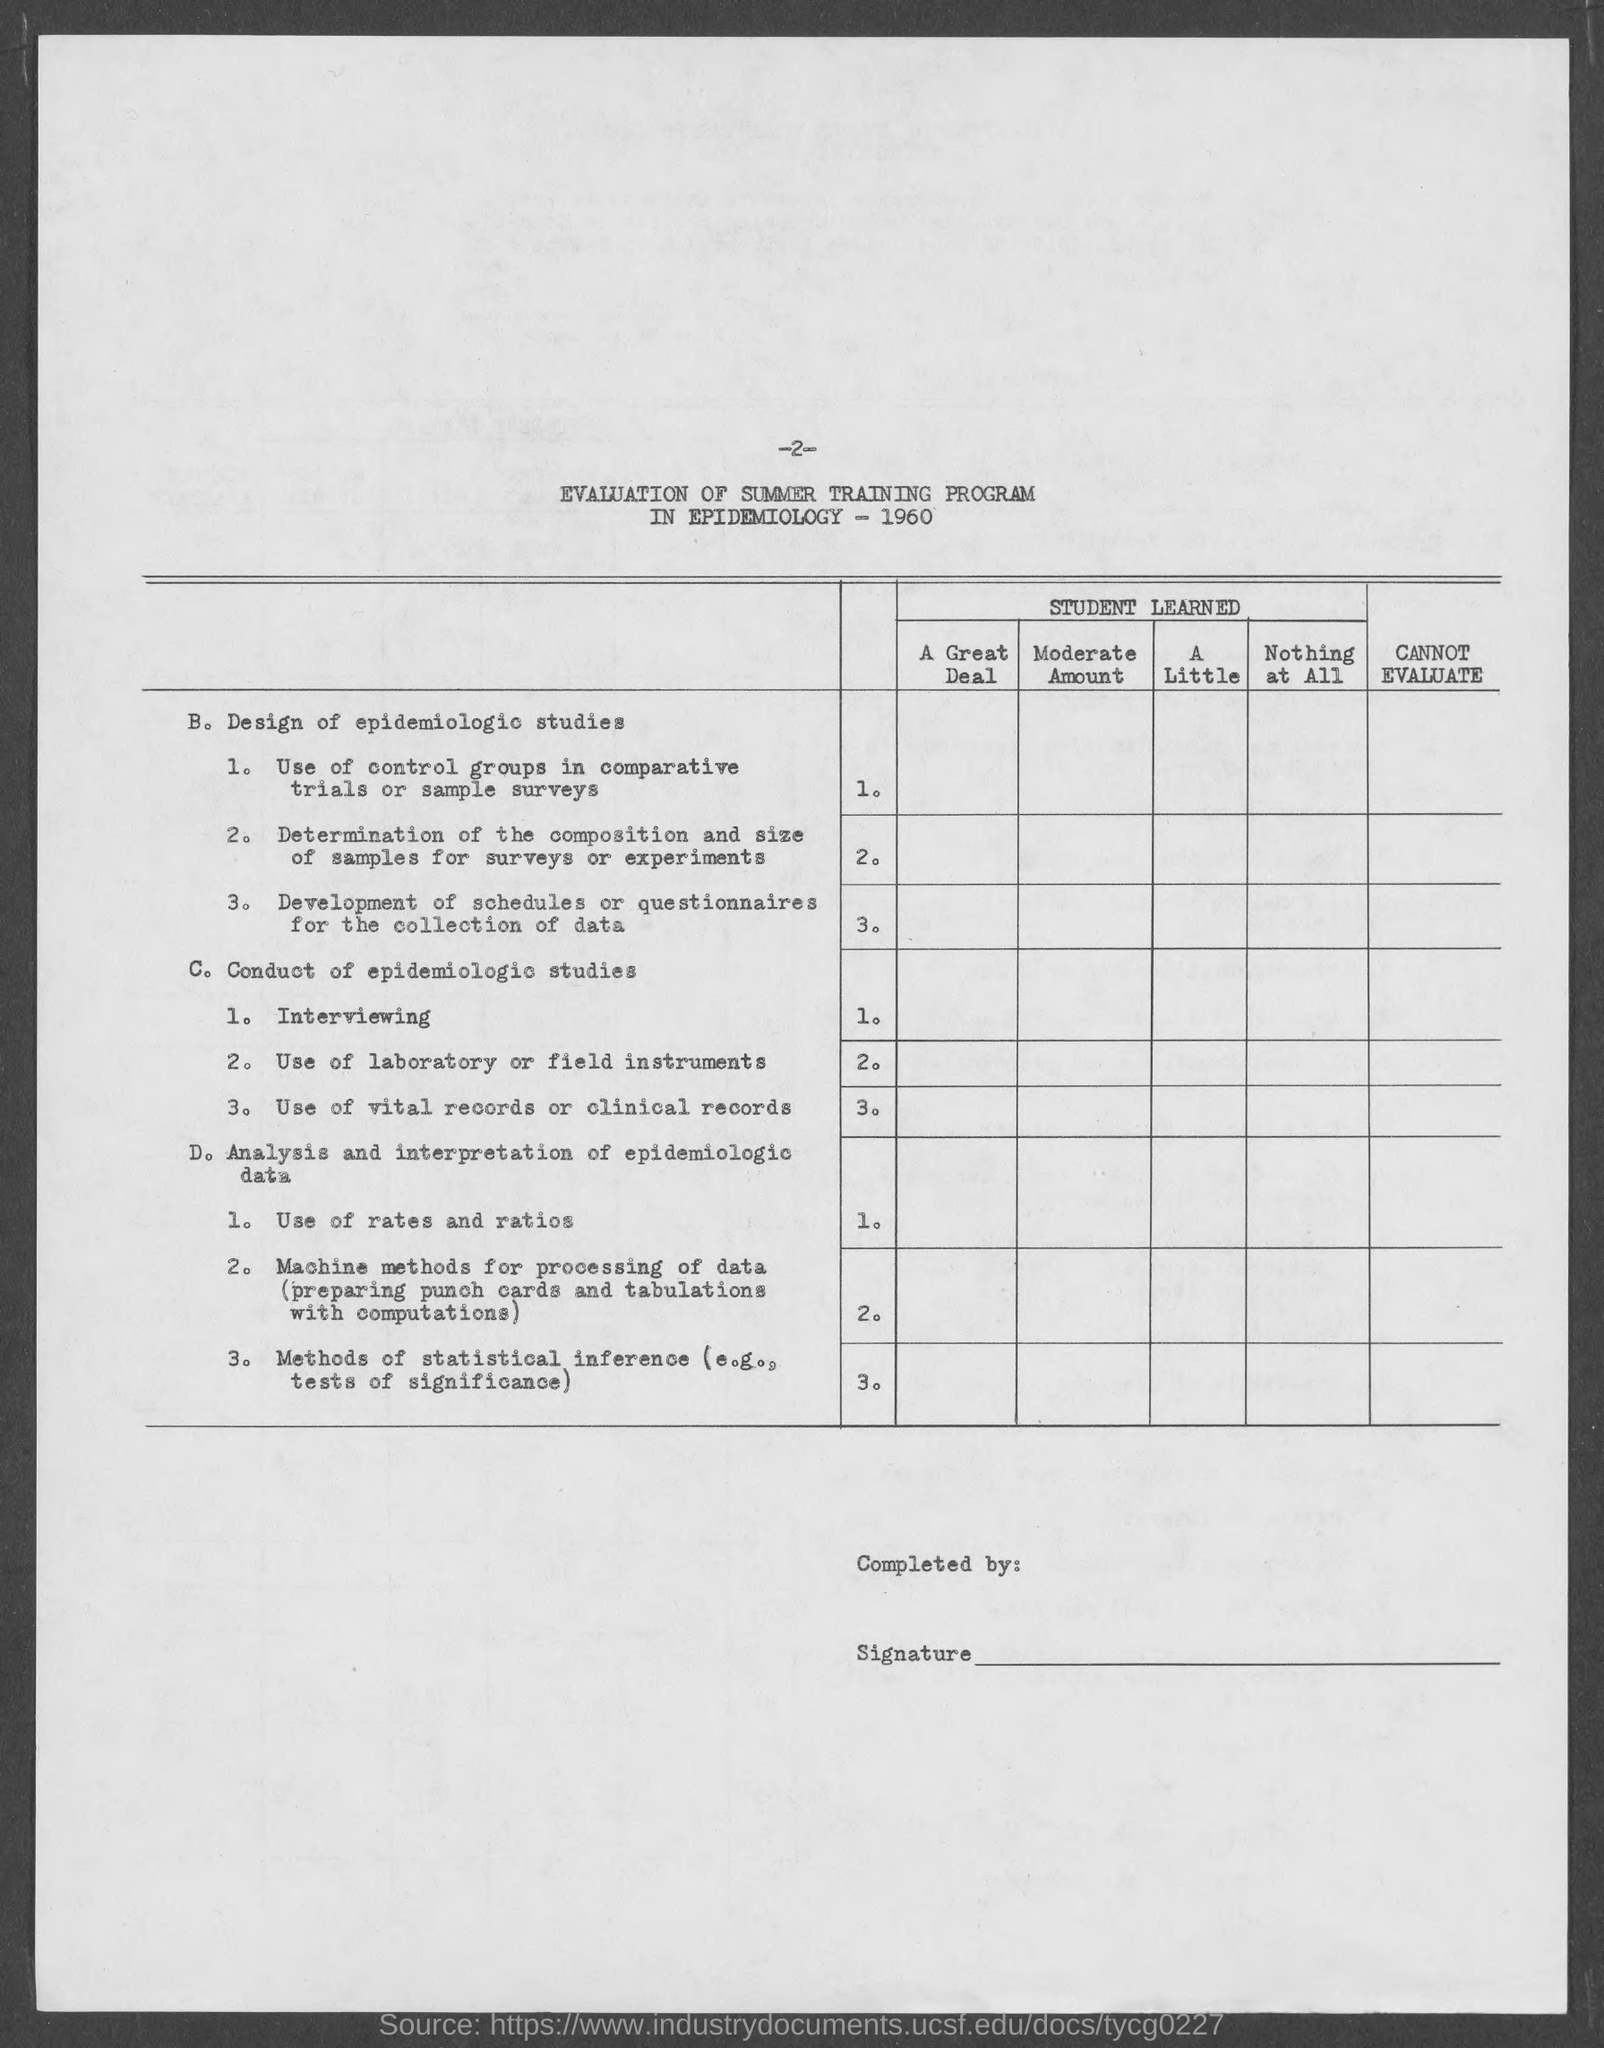What is the page no mentioned in this document?
Keep it short and to the point. -2-. 